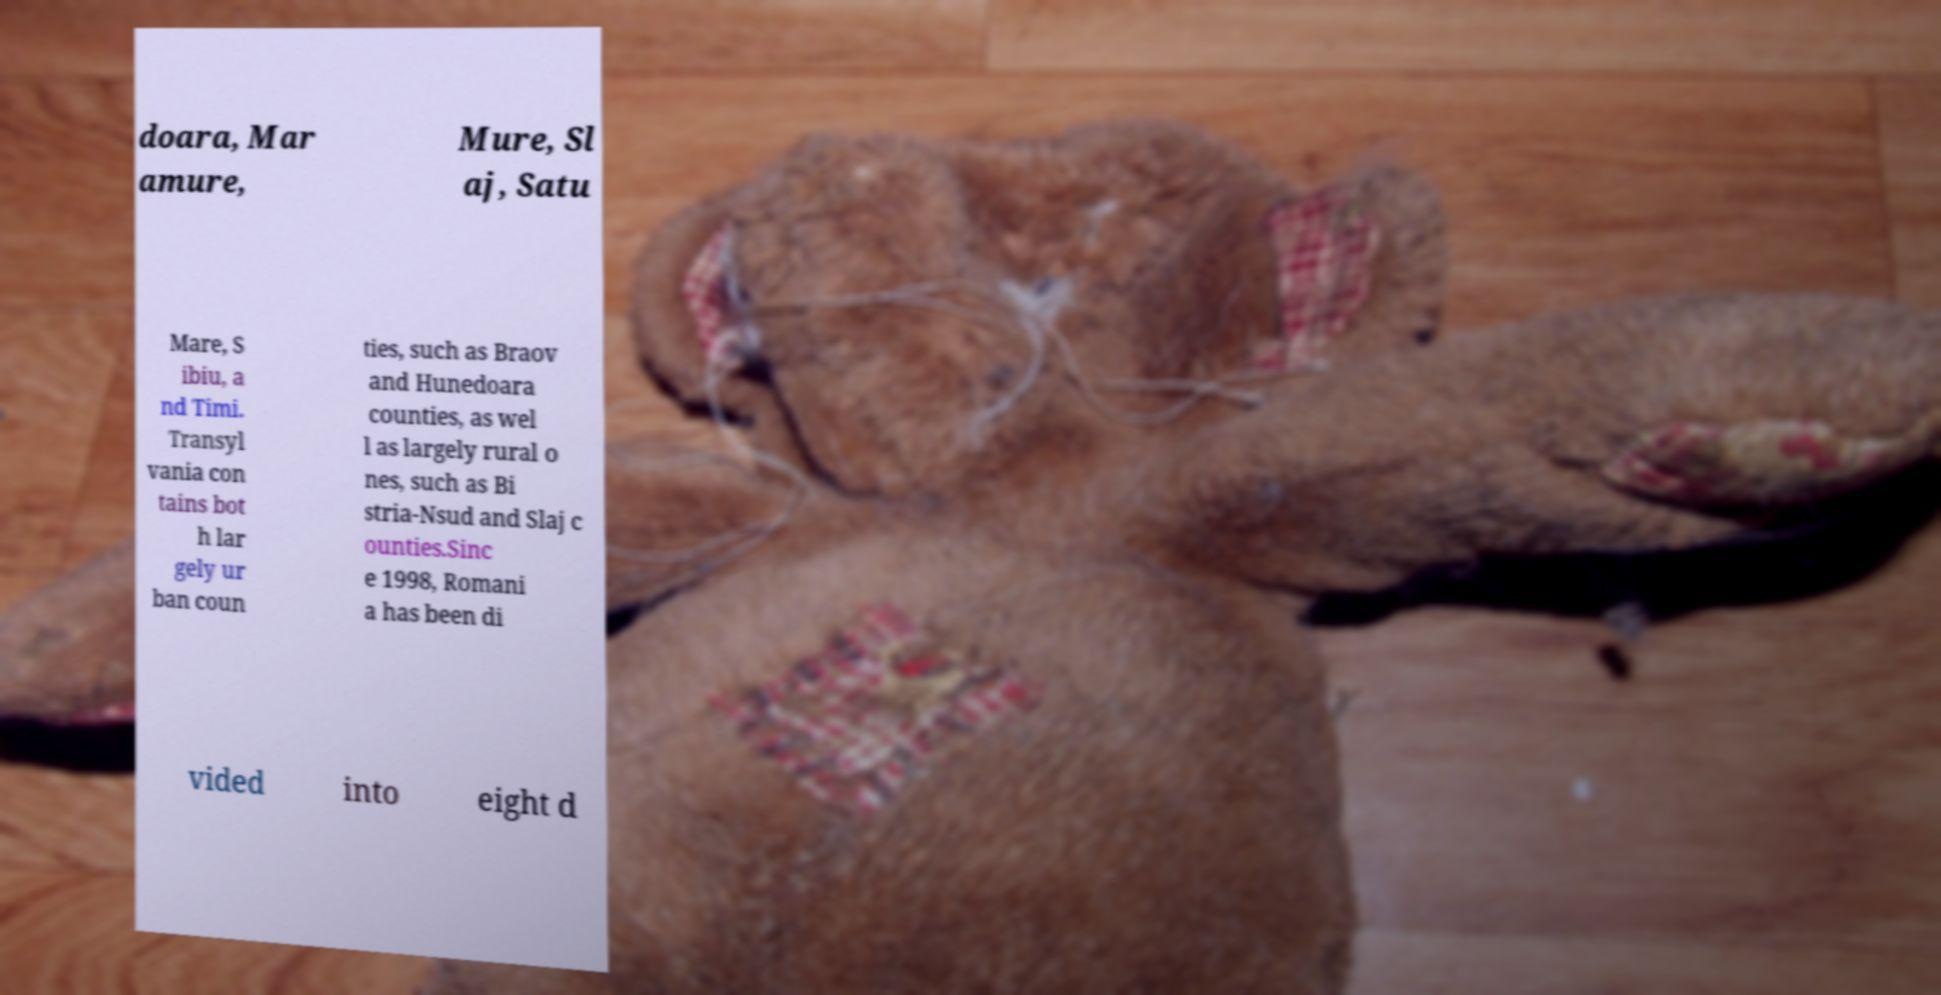Please read and relay the text visible in this image. What does it say? doara, Mar amure, Mure, Sl aj, Satu Mare, S ibiu, a nd Timi. Transyl vania con tains bot h lar gely ur ban coun ties, such as Braov and Hunedoara counties, as wel l as largely rural o nes, such as Bi stria-Nsud and Slaj c ounties.Sinc e 1998, Romani a has been di vided into eight d 